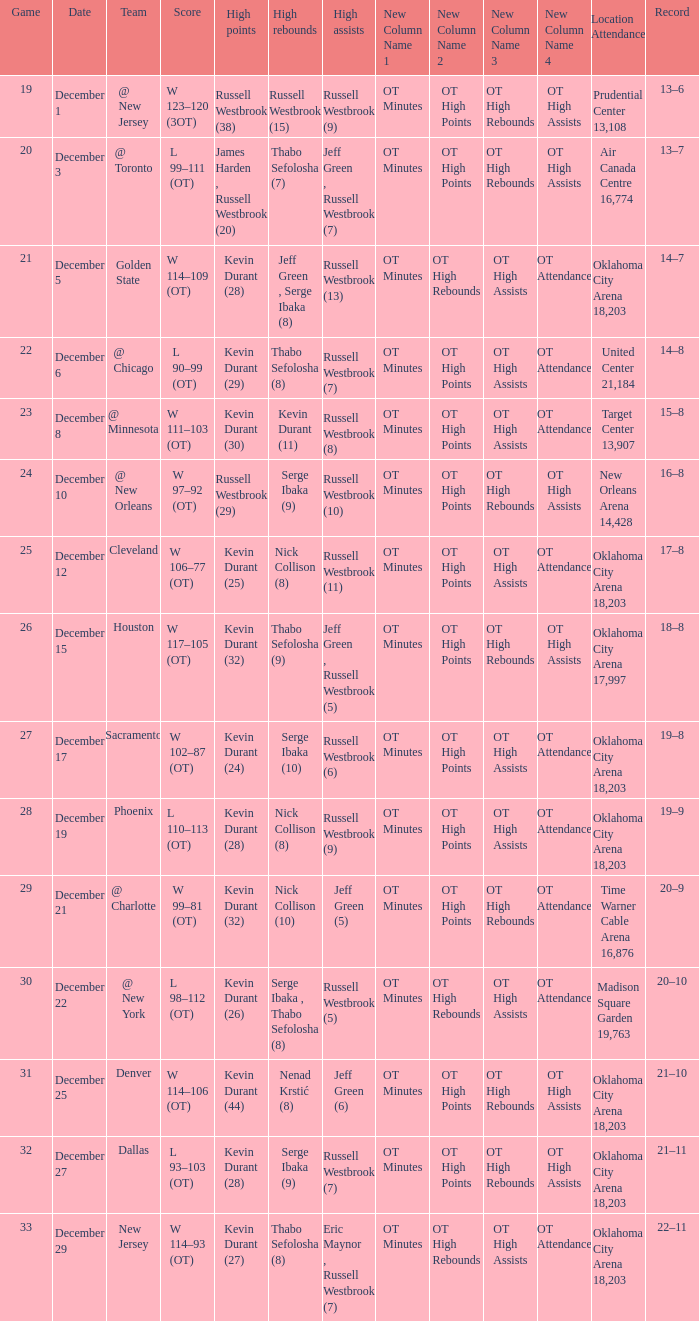Who had the high rebounds record on December 12? Nick Collison (8). 